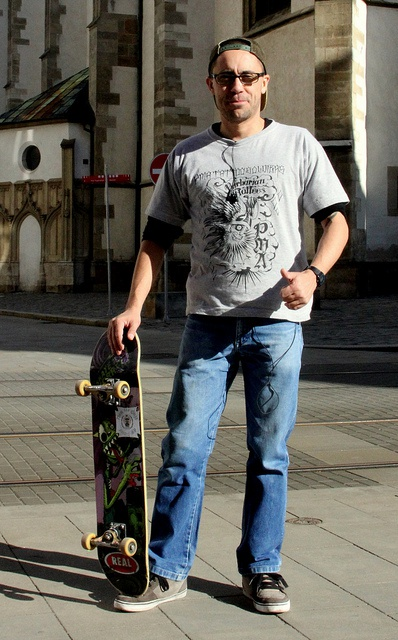Describe the objects in this image and their specific colors. I can see people in gray, black, lightgray, and darkgray tones and skateboard in gray, black, maroon, and darkgreen tones in this image. 